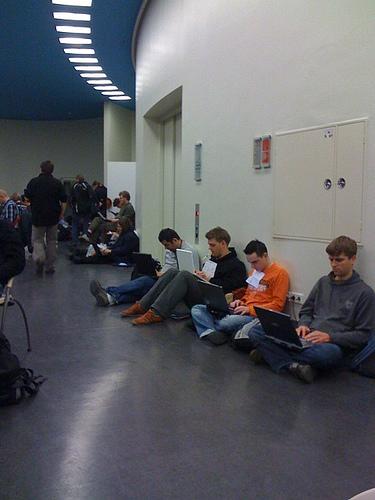What color is the computer?
Give a very brief answer. Black. What are the kids doing?
Short answer required. Studying. What is everyone sitting down doing?
Quick response, please. Using computer. Why are shadows being cast?
Give a very brief answer. Light. Is this a test waiting room?
Short answer required. Yes. Are there lights?
Short answer required. Yes. Where is the laptop?
Write a very short answer. On lap. What clothing has a rip in it?
Write a very short answer. Jeans. Is the image focused or blurry?
Write a very short answer. Focused. Is there a dinosaur in the picture?
Write a very short answer. No. 